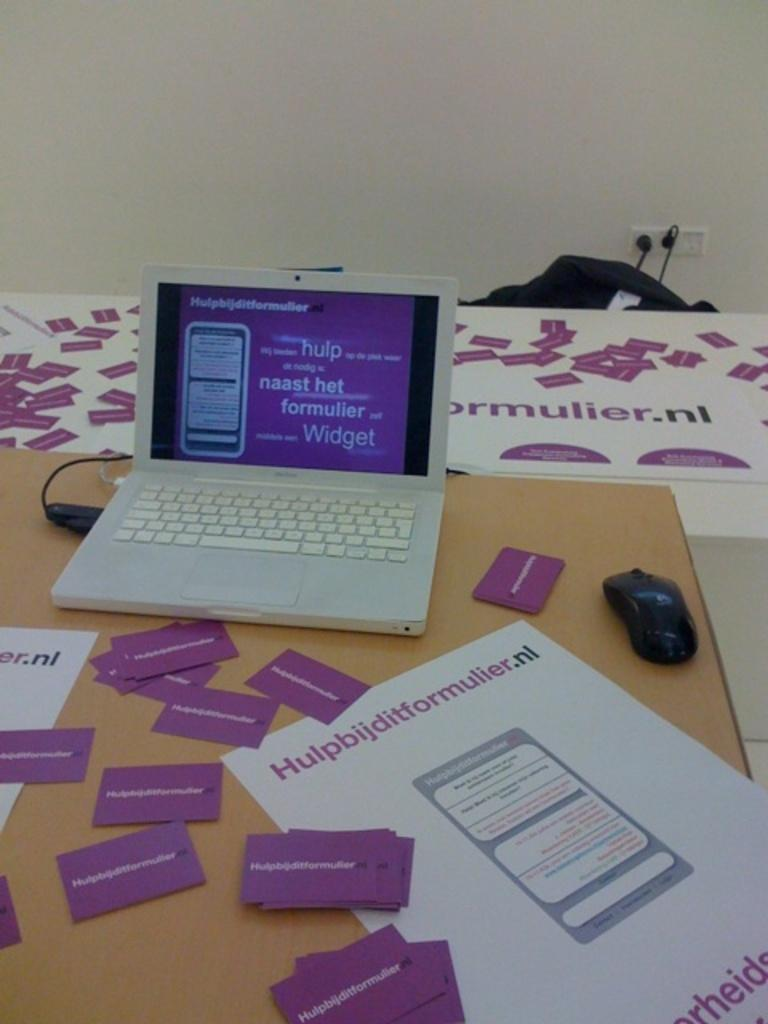Provide a one-sentence caption for the provided image. A white laptop on a table that says ormulier.nl. 